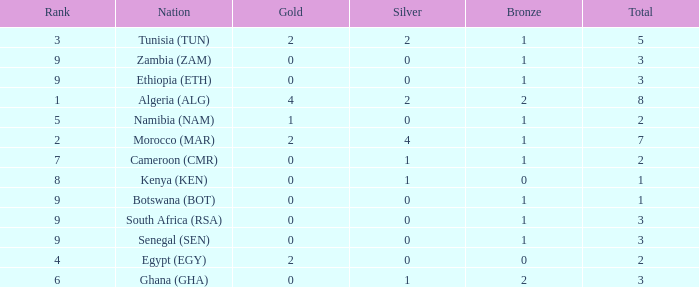What is the lowest Bronze with a Nation of egypt (egy) and with a Gold that is smaller than 2? None. Would you mind parsing the complete table? {'header': ['Rank', 'Nation', 'Gold', 'Silver', 'Bronze', 'Total'], 'rows': [['3', 'Tunisia (TUN)', '2', '2', '1', '5'], ['9', 'Zambia (ZAM)', '0', '0', '1', '3'], ['9', 'Ethiopia (ETH)', '0', '0', '1', '3'], ['1', 'Algeria (ALG)', '4', '2', '2', '8'], ['5', 'Namibia (NAM)', '1', '0', '1', '2'], ['2', 'Morocco (MAR)', '2', '4', '1', '7'], ['7', 'Cameroon (CMR)', '0', '1', '1', '2'], ['8', 'Kenya (KEN)', '0', '1', '0', '1'], ['9', 'Botswana (BOT)', '0', '0', '1', '1'], ['9', 'South Africa (RSA)', '0', '0', '1', '3'], ['9', 'Senegal (SEN)', '0', '0', '1', '3'], ['4', 'Egypt (EGY)', '2', '0', '0', '2'], ['6', 'Ghana (GHA)', '0', '1', '2', '3']]} 